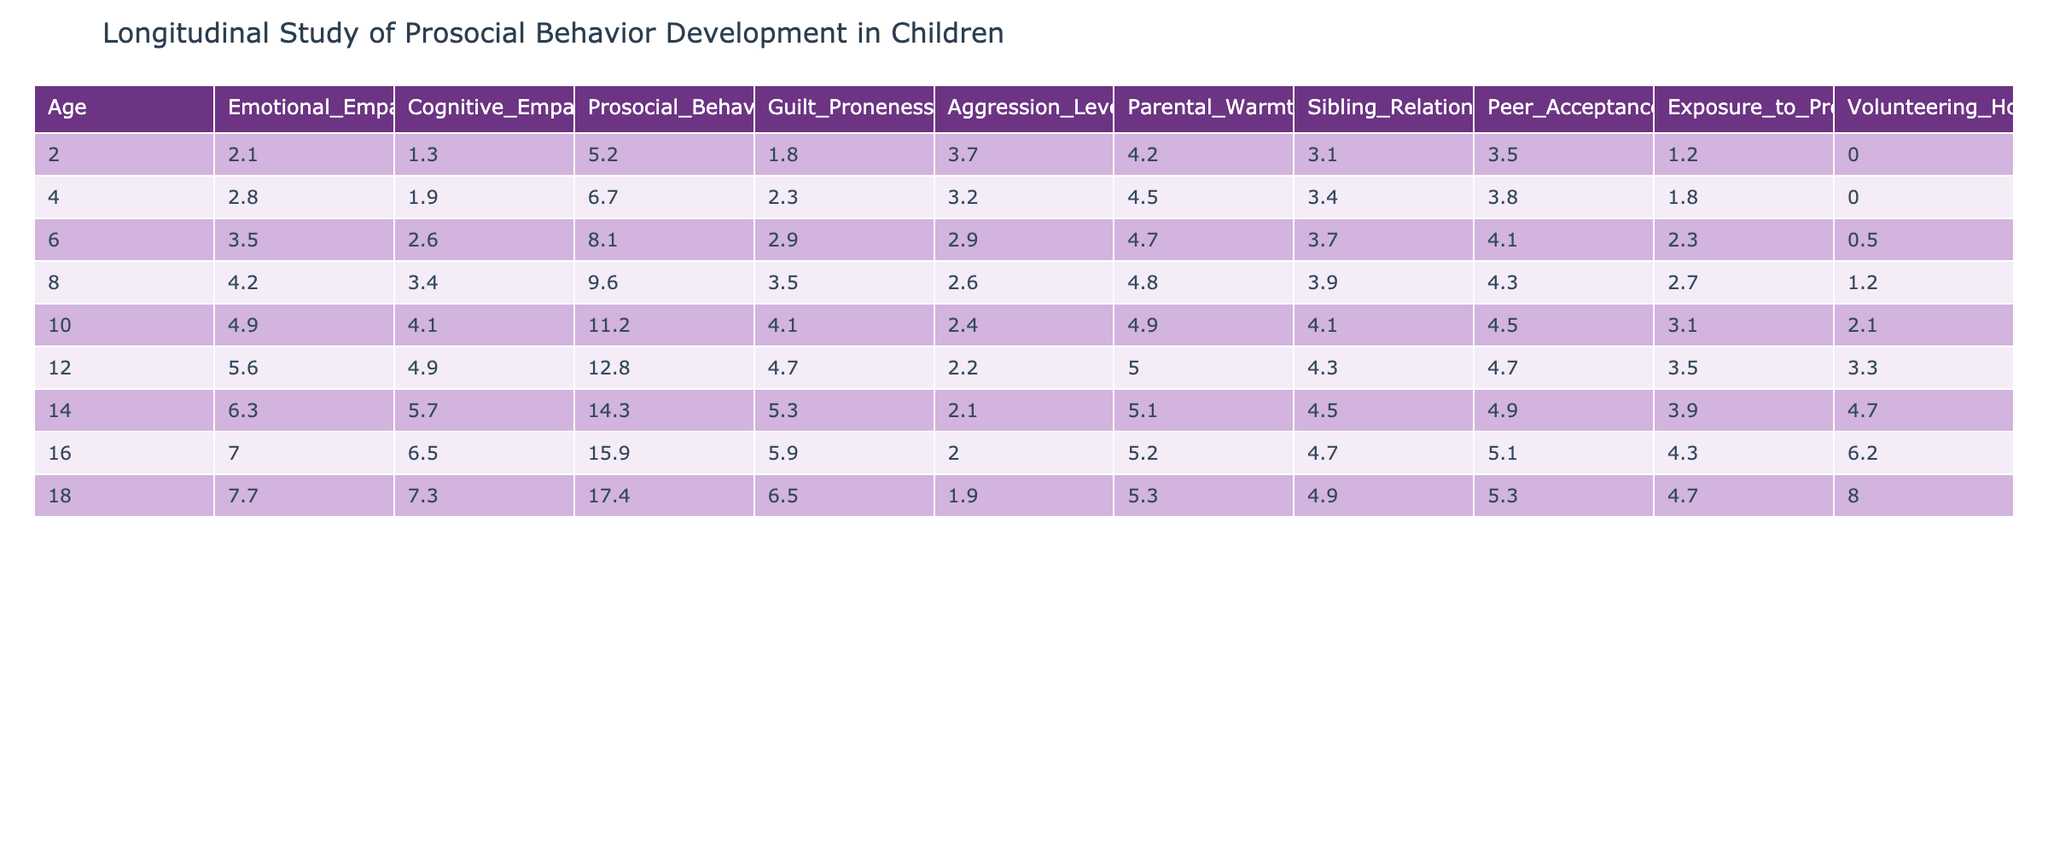What is the Emotional Empathy Score for children at age 10? From the table, look for the row where the age is 10. The Emotional Empathy Score listed for that age is 4.9.
Answer: 4.9 What was the highest Prosocial Behavior Frequency score recorded in the table? Review the Prosocial Behavior Frequency column and identify the maximum value. The highest score is 17.4, which corresponds to age 18.
Answer: 17.4 How many hours per month do children volunteer on average across all ages? To find the average volunteering hours, sum the volunteering hours for all ages: (0 + 0 + 0.5 + 1.2 + 2.1 + 3.3 + 4.7 + 6.2 + 8.0) = 25.0. There are 8 ages, therefore the average is 25.0 / 8 = 3.125.
Answer: 3.125 Does the Emotional Empathy Score increase with age? By observing the Emotional Empathy Score in each age row, it can be seen that scores increase consistently from age 2 (2.1) to age 18 (7.7), indicating a positive trend.
Answer: Yes What is the difference in Guilt Proneness scores between age 2 and age 14? To find the difference, subtract the Guilt Proneness score for age 2 (1.8) from the score for age 14 (5.3): 5.3 - 1.8 = 3.5.
Answer: 3.5 Are there any ages where the aggression level was below 2.0? Review the Aggression Level column to see if any score is below 2.0. The lowest score is 1.9 at age 18, confirming that it is indeed below 2.0.
Answer: Yes What is the average Guilt Proneness among the ages studied? First, sum the Guilt Proneness scores: 1.8 + 2.3 + 2.9 + 3.5 + 4.1 + 4.7 + 5.3 + 6.5 = 31.1. Then, divide by the number of ages (8): 31.1 / 8 = 3.8875.
Answer: 3.89 At what age do we see the most considerable increase in Prosocial Behavior Frequency compared to the previous age? Examine the changes in Prosocial Behavior Frequency from one age to the next: the greatest increase occurs from age 16 (15.9) to age 18 (17.4), with an increase of 1.5.
Answer: Age 18 What is the relationship between Parental Warmth and Emotional Empathy Score across different ages? Observe both the Parental Warmth and Emotional Empathy Score columns. As age increases, both scores tend to increase consistently, suggesting a possible positive correlation.
Answer: Positive correlation What age had the highest Cognitive Empathy Score, and what was that score? Check the Cognitive Empathy Score column for the maximum value. The highest score occurs at age 18 with a score of 7.3.
Answer: Age 18, Score: 7.3 